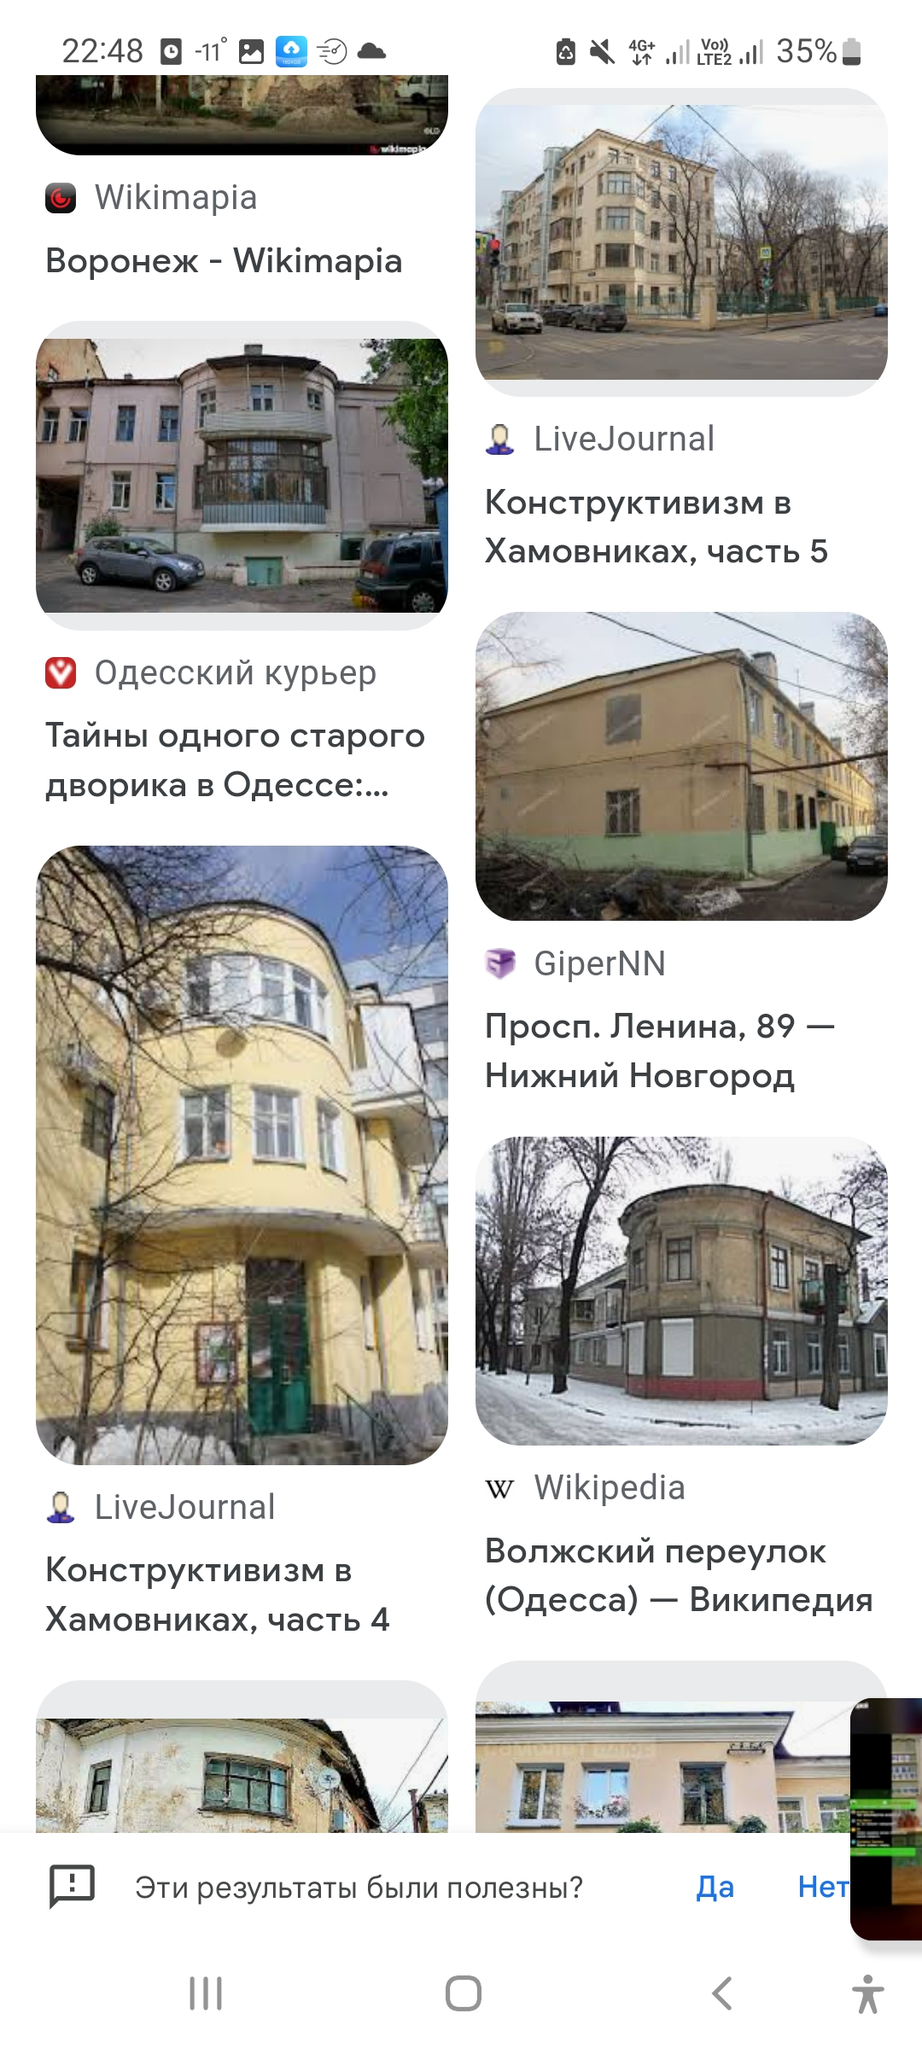How is this architecture style called? The architecture style shown in the images can be identified as Constructivism. Constructivism was an architectural and artistic philosophy that originated in Russia from around 1913 to the 1940s. It was a modernist movement that embraced technology and industrial materials, aiming to reflect modern society in its architecture. Constructivist buildings often feature geometric shapes, a lack of ornamentation, and the use of modern materials such as steel, glass, and concrete. The text in the images, which is in Russian, also suggests Constructivism ("Конструктивизм"), confirming the architectural style. How many constructivist buildings are there in Chelyabinsk? The image you've provided appears to show search results for constructivist architecture, but the locations mentioned in the search results, such as Voronezh, Odessa, and Nizhny Novgorod, are not in Chelyabinsk. This suggests that the search query may have been for constructivist buildings in general, rather than specifically in Chelyabinsk.

As for the number of constructivist buildings in Chelyabinsk, I don't have the exact number. Constructivism was a popular architectural style in the Soviet Union in the 1920s and 1930s, and many cities, including Chelyabinsk, have examples of this architectural style. To get an accurate count, you would likely need to consult a local architectural guide or a database that specializes in historical buildings in Chelyabinsk. 